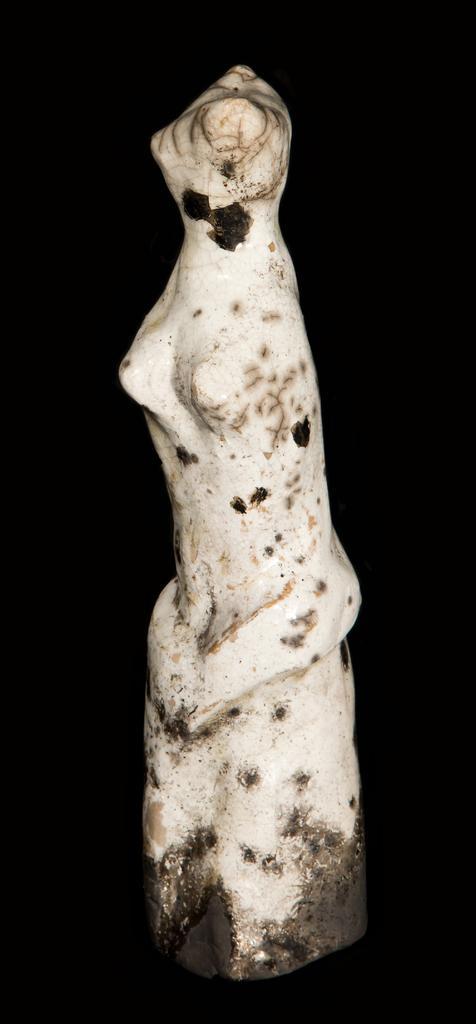How would you summarize this image in a sentence or two? In this picture we can see a sculpture. Background is black in color. 